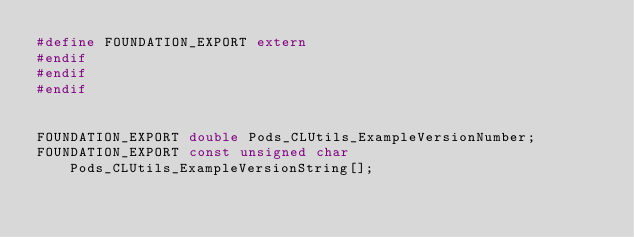Convert code to text. <code><loc_0><loc_0><loc_500><loc_500><_C_>#define FOUNDATION_EXPORT extern
#endif
#endif
#endif


FOUNDATION_EXPORT double Pods_CLUtils_ExampleVersionNumber;
FOUNDATION_EXPORT const unsigned char Pods_CLUtils_ExampleVersionString[];

</code> 